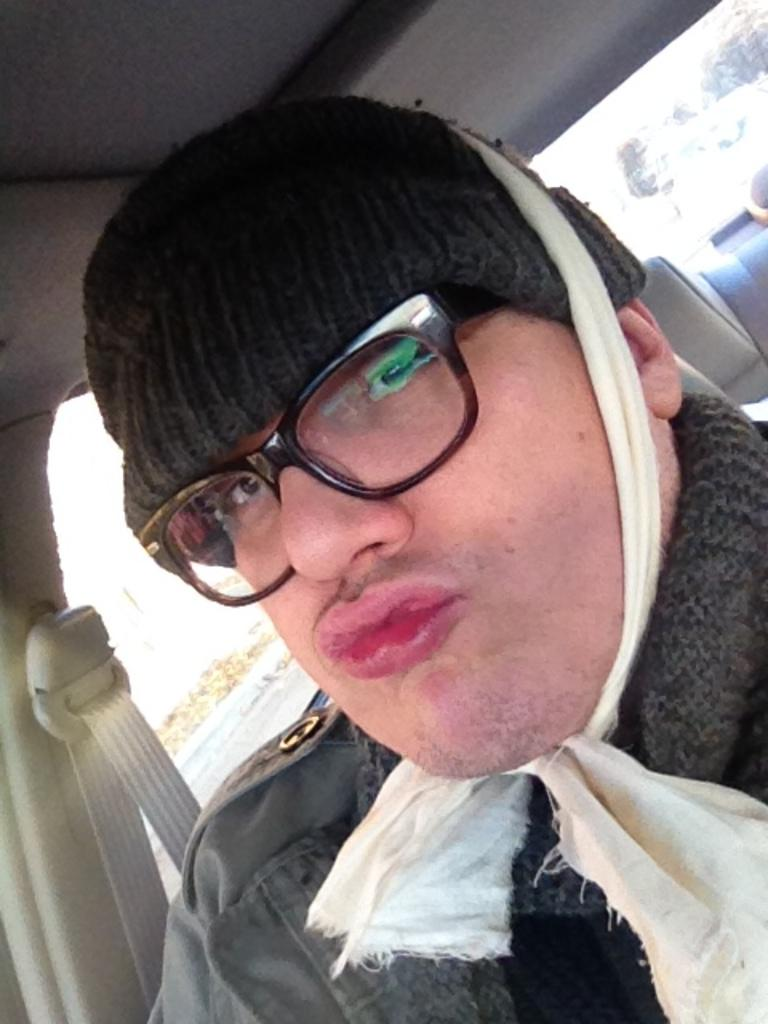What is the main subject of the image? There is a person in the image. What is the person wearing? The person is wearing a black cap, a black dress, and black spectacles. Where is the person located in the image? The person is sitting in a vehicle. What can be seen through the glass of the vehicle? Trees and the sky are visible through the glass of the vehicle. What type of lamp is hanging from the ceiling in the image? There is no lamp present in the image; it features a person sitting in a vehicle with trees and the sky visible through the glass. 